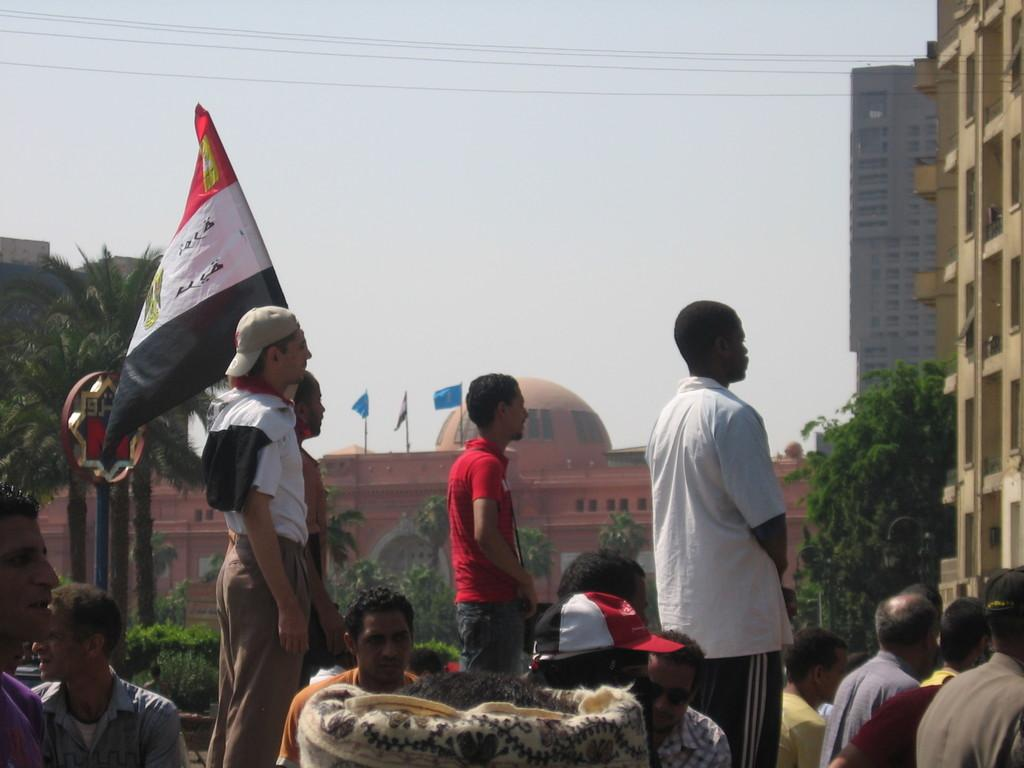What can be seen in the image? There are men standing in the image, along with buildings, trees, a flag, and the sky. Can you describe the men in the image? The men are standing in the image, but their specific actions or appearances are not mentioned in the facts. What type of structures are present in the image? The buildings in the image are mentioned, but their specific characteristics are not described. What is the flag attached to in the image? The facts do not specify what the flag is attached to. What is the color of the sky in the image? The color of the sky is not mentioned in the facts. What type of wine is being served at the plot of land in the image? There is no mention of wine or a plot of land in the image. 